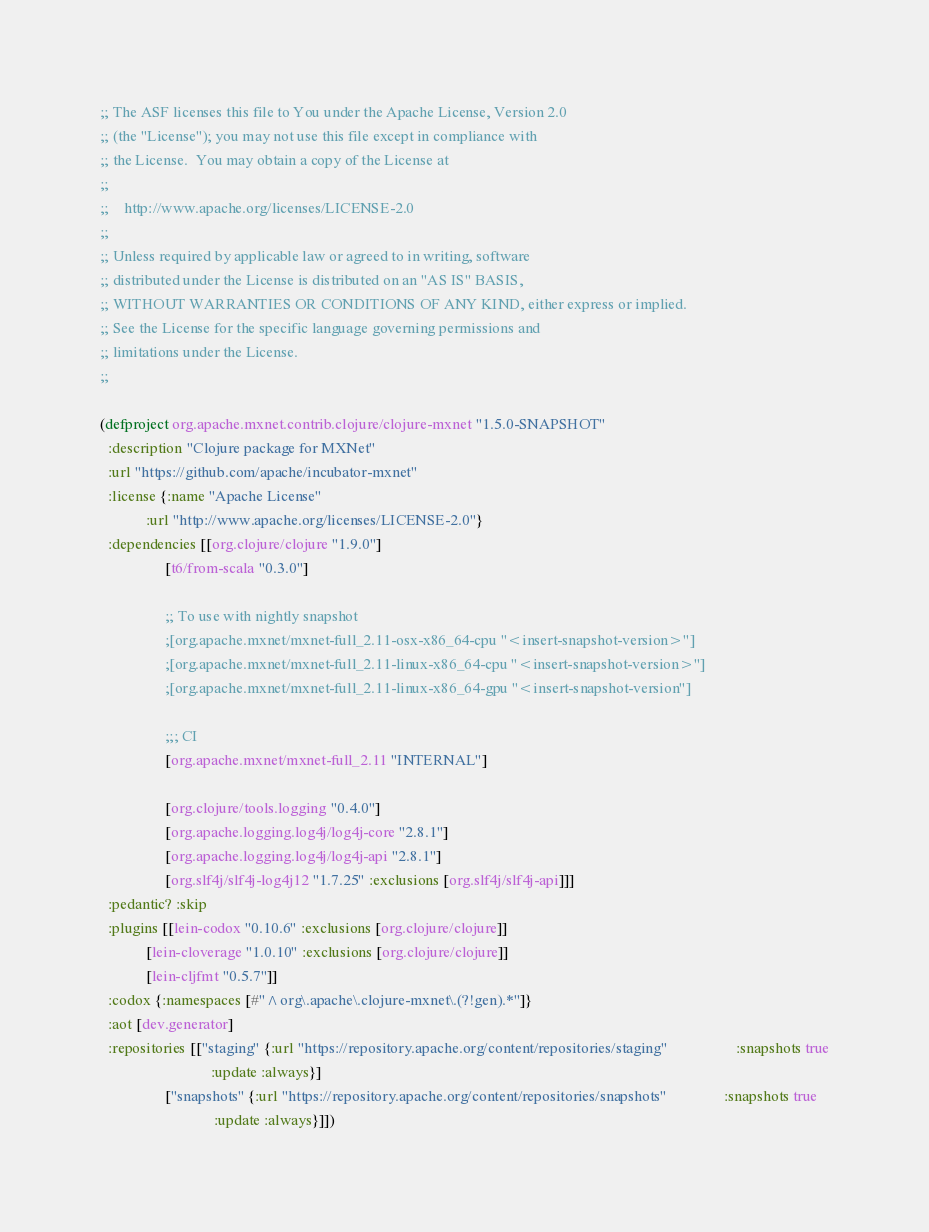<code> <loc_0><loc_0><loc_500><loc_500><_Clojure_>;; The ASF licenses this file to You under the Apache License, Version 2.0
;; (the "License"); you may not use this file except in compliance with
;; the License.  You may obtain a copy of the License at
;;
;;    http://www.apache.org/licenses/LICENSE-2.0
;;
;; Unless required by applicable law or agreed to in writing, software
;; distributed under the License is distributed on an "AS IS" BASIS,
;; WITHOUT WARRANTIES OR CONDITIONS OF ANY KIND, either express or implied.
;; See the License for the specific language governing permissions and
;; limitations under the License.
;;

(defproject org.apache.mxnet.contrib.clojure/clojure-mxnet "1.5.0-SNAPSHOT"
  :description "Clojure package for MXNet"
  :url "https://github.com/apache/incubator-mxnet"
  :license {:name "Apache License"
            :url "http://www.apache.org/licenses/LICENSE-2.0"}
  :dependencies [[org.clojure/clojure "1.9.0"]
                 [t6/from-scala "0.3.0"]

                 ;; To use with nightly snapshot
                 ;[org.apache.mxnet/mxnet-full_2.11-osx-x86_64-cpu "<insert-snapshot-version>"]
                 ;[org.apache.mxnet/mxnet-full_2.11-linux-x86_64-cpu "<insert-snapshot-version>"]
                 ;[org.apache.mxnet/mxnet-full_2.11-linux-x86_64-gpu "<insert-snapshot-version"]

                 ;;; CI
                 [org.apache.mxnet/mxnet-full_2.11 "INTERNAL"]

                 [org.clojure/tools.logging "0.4.0"]
                 [org.apache.logging.log4j/log4j-core "2.8.1"]
                 [org.apache.logging.log4j/log4j-api "2.8.1"]
                 [org.slf4j/slf4j-log4j12 "1.7.25" :exclusions [org.slf4j/slf4j-api]]]
  :pedantic? :skip
  :plugins [[lein-codox "0.10.6" :exclusions [org.clojure/clojure]]
            [lein-cloverage "1.0.10" :exclusions [org.clojure/clojure]]
            [lein-cljfmt "0.5.7"]]
  :codox {:namespaces [#"^org\.apache\.clojure-mxnet\.(?!gen).*"]}
  :aot [dev.generator]
  :repositories [["staging" {:url "https://repository.apache.org/content/repositories/staging"                  :snapshots true
                             :update :always}]
                 ["snapshots" {:url "https://repository.apache.org/content/repositories/snapshots"               :snapshots true
                              :update :always}]])
</code> 